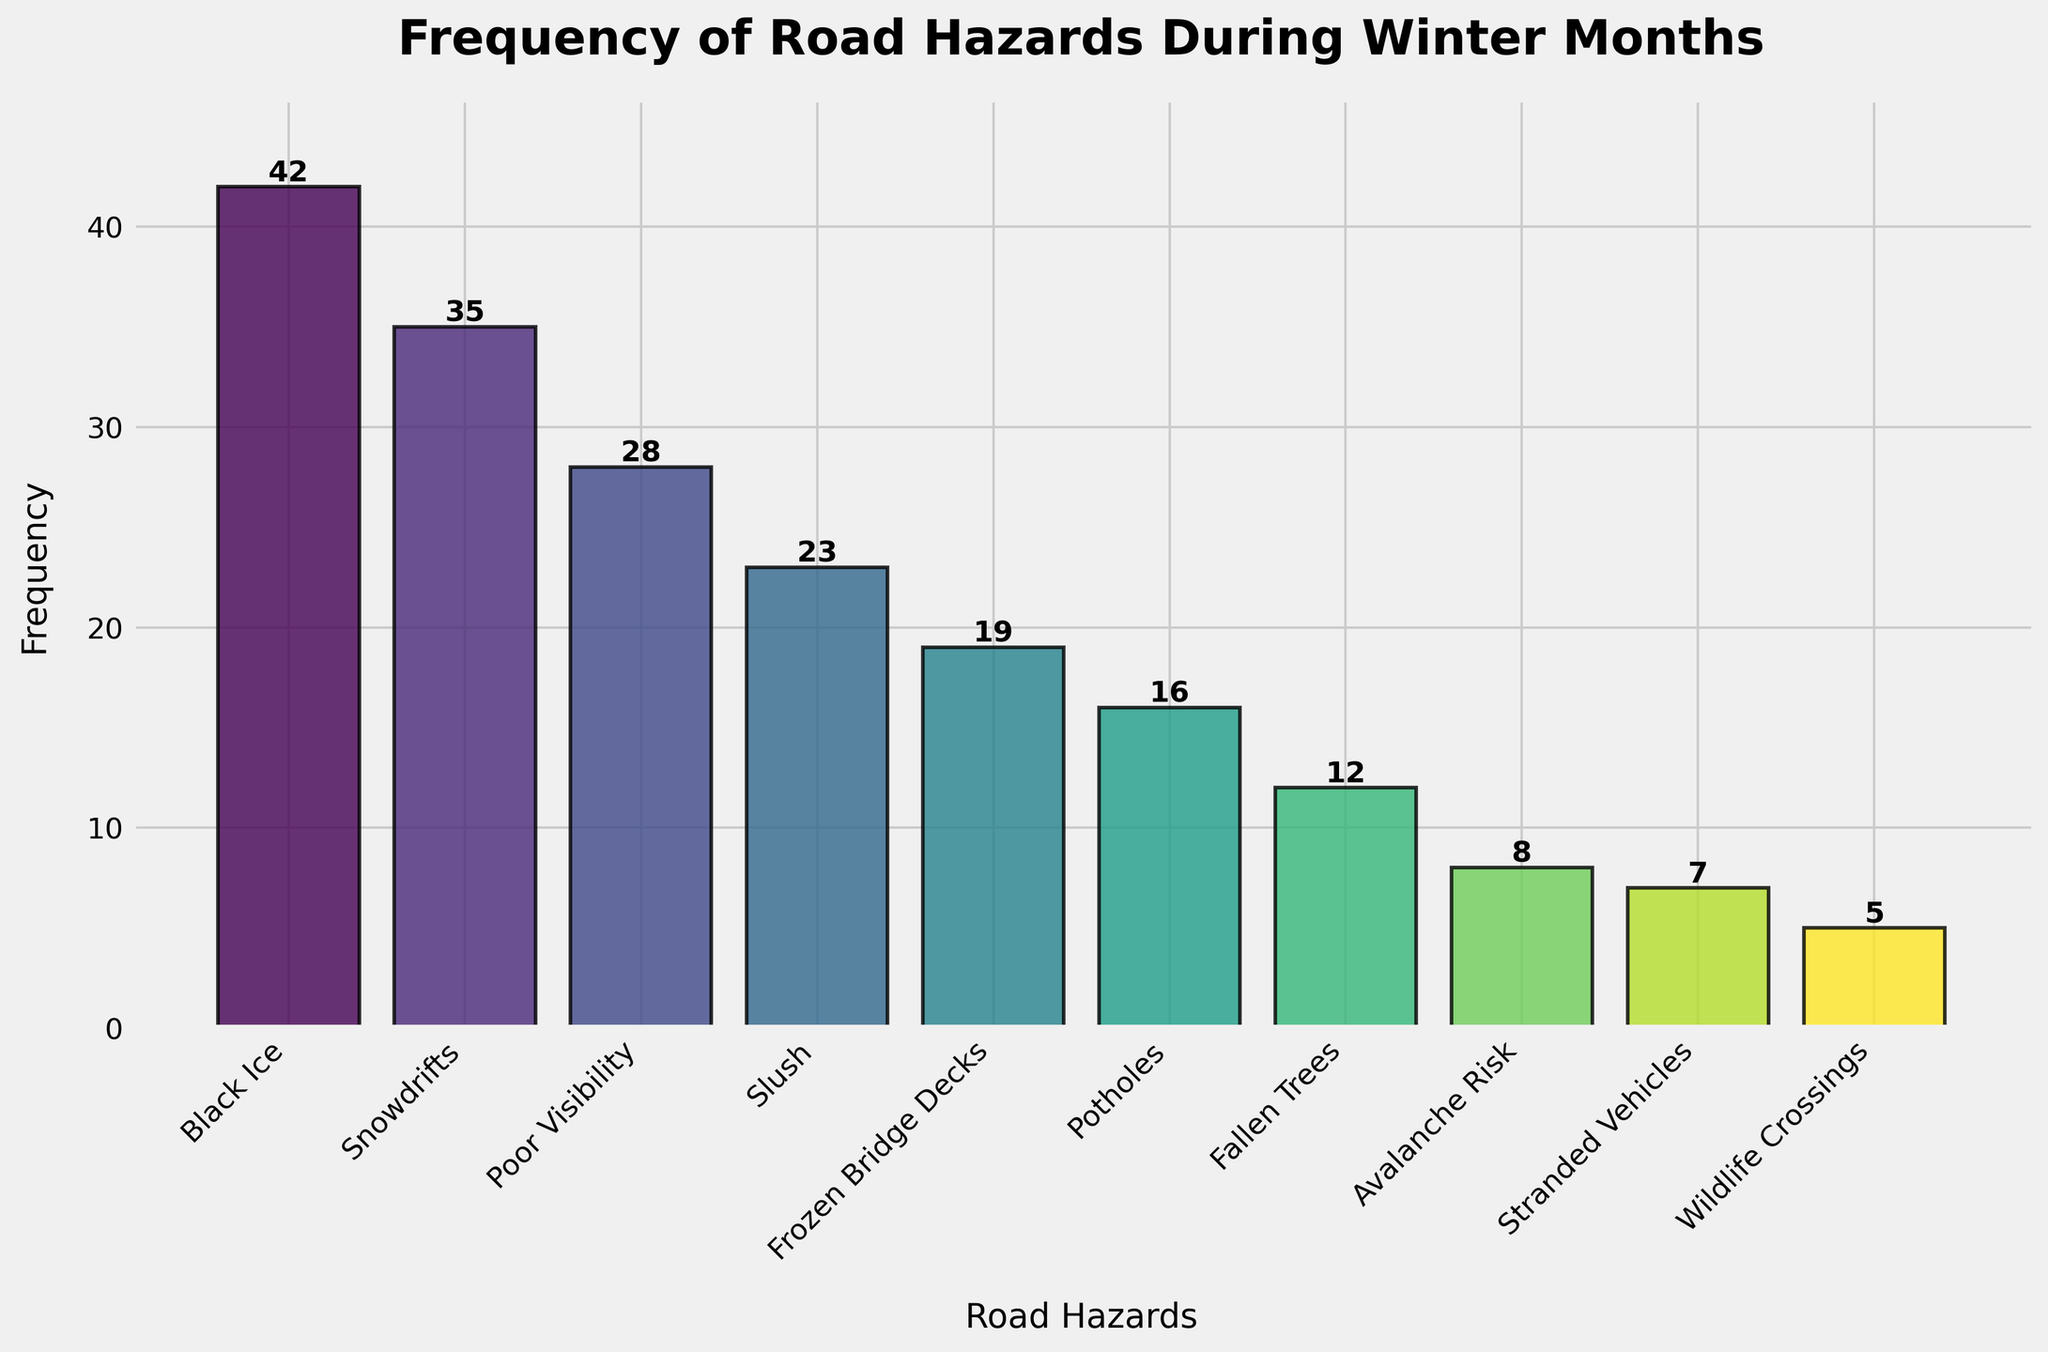What's the most frequently encountered road hazard during winter months? By looking at the heights of the bars, the tallest bar represents the most frequently encountered road hazard. The tallest bar corresponds to "Black Ice" with a frequency of 42.
Answer: Black Ice Which road hazard has the lowest frequency? The shortest bar in the plot represents the road hazard with the lowest frequency, which is "Wildlife Crossings" with a frequency of 5.
Answer: Wildlife Crossings How many more times was "Black Ice" encountered compared to "Slush"? Subtract the frequency of "Slush" from the frequency of "Black Ice": 42 (Black Ice) - 23 (Slush) = 19.
Answer: 19 What is the total frequency for hazards related to frozen conditions (Black Ice, Frozen Bridge Decks)? Add the frequencies of Black Ice (42) and Frozen Bridge Decks (19): 42 + 19 = 61.
Answer: 61 Is the frequency of "Snowdrifts" higher than "Poor Visibility"? Compare the heights of the bars for "Snowdrifts" and "Poor Visibility". Snowdrifts have a higher frequency (35) compared to Poor Visibility (28).
Answer: Yes What's the combined frequency of the three least common road hazards? Add the frequencies of the three least common hazards: Wildlife Crossings (5) + Stranded Vehicles (7) + Avalanche Risk (8): 5 + 7 + 8 = 20.
Answer: 20 Which road hazard with a frequency greater than 20 has the smallest frequency? From the categories with frequencies higher than 20, "Slush" has the smallest frequency of 23.
Answer: Slush What percentage of the total frequency is represented by "Potholes"? First, find the total frequency of all hazards: 42+35+28+23+19+16+12+8+7+5 = 195. Now calculate the percentage: (16 / 195) * 100 ≈ 8.21%.
Answer: 8.21% How much more frequently are "Snowdrifts" encountered than "Fallen Trees"? Subtract the frequency of "Fallen Trees" from "Snowdrifts": 35 - 12 = 23.
Answer: 23 What's the median frequency of the road hazards listed? Arrange the frequencies in ascending order: 5, 7, 8, 12, 16, 19, 23, 28, 35, 42. The median would be the average of the 5th and 6th values: (16 + 19) / 2 = 17.5.
Answer: 17.5 